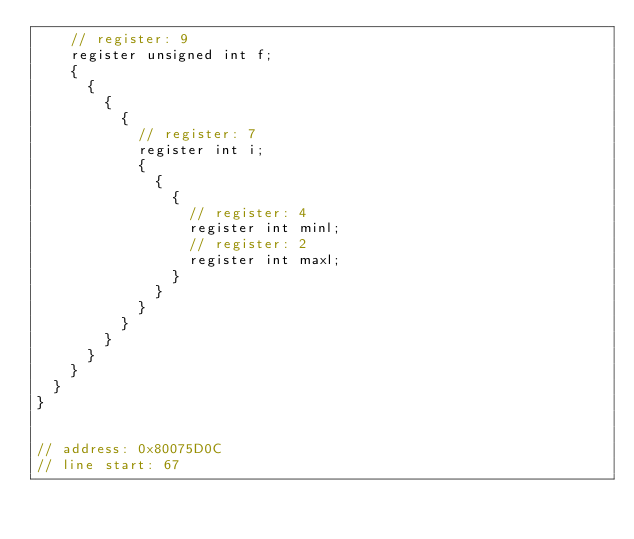<code> <loc_0><loc_0><loc_500><loc_500><_C++_>		// register: 9
		register unsigned int f;
		{
			{
				{
					{
						// register: 7
						register int i;
						{
							{
								{
									// register: 4
									register int minl;
									// register: 2
									register int maxl;
								}
							}
						}
					}
				}
			}
		}
	}
}


// address: 0x80075D0C
// line start: 67</code> 